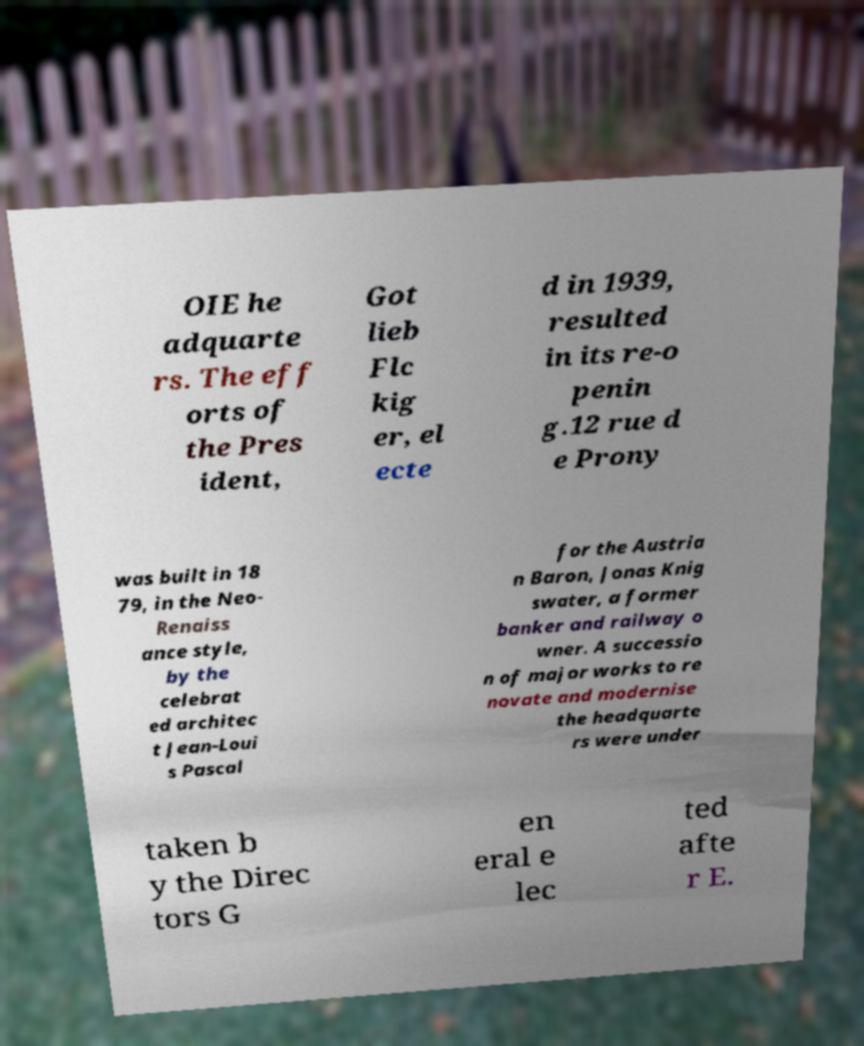Can you read and provide the text displayed in the image?This photo seems to have some interesting text. Can you extract and type it out for me? OIE he adquarte rs. The eff orts of the Pres ident, Got lieb Flc kig er, el ecte d in 1939, resulted in its re-o penin g.12 rue d e Prony was built in 18 79, in the Neo- Renaiss ance style, by the celebrat ed architec t Jean-Loui s Pascal for the Austria n Baron, Jonas Knig swater, a former banker and railway o wner. A successio n of major works to re novate and modernise the headquarte rs were under taken b y the Direc tors G en eral e lec ted afte r E. 